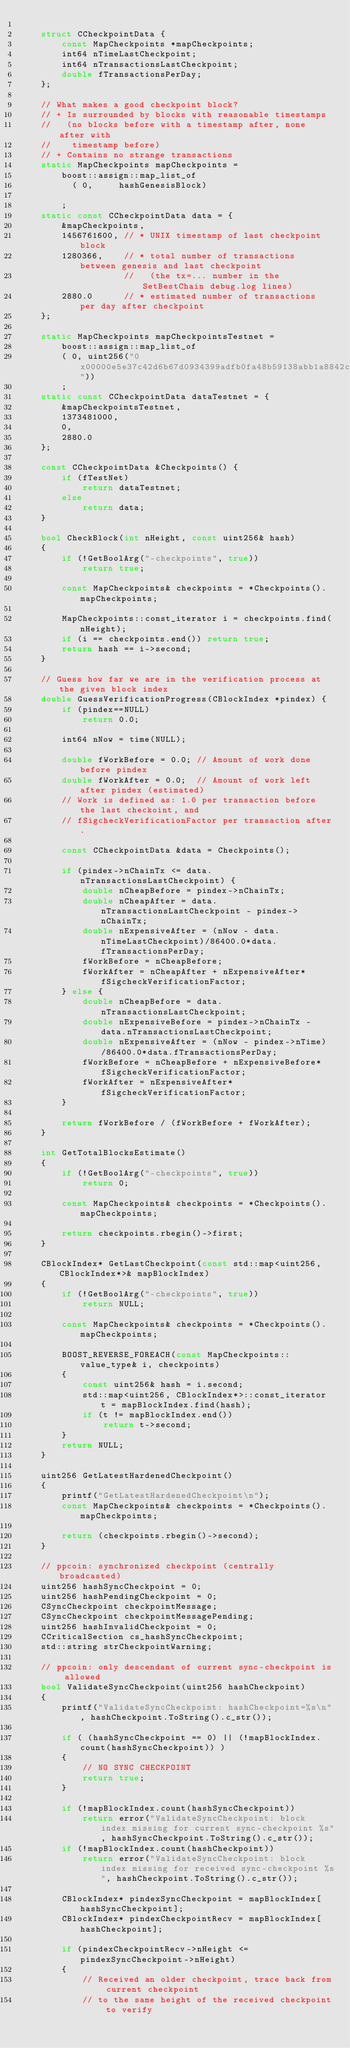<code> <loc_0><loc_0><loc_500><loc_500><_C++_>
    struct CCheckpointData {
        const MapCheckpoints *mapCheckpoints;
        int64 nTimeLastCheckpoint;
        int64 nTransactionsLastCheckpoint;
        double fTransactionsPerDay;
    };

    // What makes a good checkpoint block?
    // + Is surrounded by blocks with reasonable timestamps
    //   (no blocks before with a timestamp after, none after with
    //    timestamp before)
    // + Contains no strange transactions
    static MapCheckpoints mapCheckpoints =
        boost::assign::map_list_of
          ( 0,     hashGenesisBlock)

        ;
    static const CCheckpointData data = {
        &mapCheckpoints,
        1456761600, // * UNIX timestamp of last checkpoint block
        1280366,    // * total number of transactions between genesis and last checkpoint
                    //   (the tx=... number in the SetBestChain debug.log lines)
        2880.0      // * estimated number of transactions per day after checkpoint
    };

    static MapCheckpoints mapCheckpointsTestnet = 
        boost::assign::map_list_of
        ( 0, uint256("0x00000e5e37c42d6b67d0934399adfb0fa48b59138abb1a8842c88f4ca3d4ec96"))
        ;
    static const CCheckpointData dataTestnet = {
        &mapCheckpointsTestnet,
        1373481000,
        0,
        2880.0
    };

    const CCheckpointData &Checkpoints() {
        if (fTestNet)
            return dataTestnet;
        else
            return data;
    }

    bool CheckBlock(int nHeight, const uint256& hash)
    {
        if (!GetBoolArg("-checkpoints", true))
            return true;

        const MapCheckpoints& checkpoints = *Checkpoints().mapCheckpoints;

        MapCheckpoints::const_iterator i = checkpoints.find(nHeight);
        if (i == checkpoints.end()) return true;
        return hash == i->second;
    }

    // Guess how far we are in the verification process at the given block index
    double GuessVerificationProgress(CBlockIndex *pindex) {
        if (pindex==NULL)
            return 0.0;

        int64 nNow = time(NULL);

        double fWorkBefore = 0.0; // Amount of work done before pindex
        double fWorkAfter = 0.0;  // Amount of work left after pindex (estimated)
        // Work is defined as: 1.0 per transaction before the last checkoint, and
        // fSigcheckVerificationFactor per transaction after.

        const CCheckpointData &data = Checkpoints();

        if (pindex->nChainTx <= data.nTransactionsLastCheckpoint) {
            double nCheapBefore = pindex->nChainTx;
            double nCheapAfter = data.nTransactionsLastCheckpoint - pindex->nChainTx;
            double nExpensiveAfter = (nNow - data.nTimeLastCheckpoint)/86400.0*data.fTransactionsPerDay;
            fWorkBefore = nCheapBefore;
            fWorkAfter = nCheapAfter + nExpensiveAfter*fSigcheckVerificationFactor;
        } else {
            double nCheapBefore = data.nTransactionsLastCheckpoint;
            double nExpensiveBefore = pindex->nChainTx - data.nTransactionsLastCheckpoint;
            double nExpensiveAfter = (nNow - pindex->nTime)/86400.0*data.fTransactionsPerDay;
            fWorkBefore = nCheapBefore + nExpensiveBefore*fSigcheckVerificationFactor;
            fWorkAfter = nExpensiveAfter*fSigcheckVerificationFactor;
        }

        return fWorkBefore / (fWorkBefore + fWorkAfter);
    }

    int GetTotalBlocksEstimate()
    {
        if (!GetBoolArg("-checkpoints", true))
            return 0;

        const MapCheckpoints& checkpoints = *Checkpoints().mapCheckpoints;

        return checkpoints.rbegin()->first;
    }

    CBlockIndex* GetLastCheckpoint(const std::map<uint256, CBlockIndex*>& mapBlockIndex)
    {
        if (!GetBoolArg("-checkpoints", true))
            return NULL;

        const MapCheckpoints& checkpoints = *Checkpoints().mapCheckpoints;

        BOOST_REVERSE_FOREACH(const MapCheckpoints::value_type& i, checkpoints)
        {
            const uint256& hash = i.second;
            std::map<uint256, CBlockIndex*>::const_iterator t = mapBlockIndex.find(hash);
            if (t != mapBlockIndex.end())
                return t->second;
        }
        return NULL;
    }
    
    uint256 GetLatestHardenedCheckpoint()
    {
        printf("GetLatestHardenedCheckpoint\n");
        const MapCheckpoints& checkpoints = *Checkpoints().mapCheckpoints;
        
        return (checkpoints.rbegin()->second);
    }
 
    // ppcoin: synchronized checkpoint (centrally broadcasted)
    uint256 hashSyncCheckpoint = 0;
    uint256 hashPendingCheckpoint = 0;
    CSyncCheckpoint checkpointMessage;
    CSyncCheckpoint checkpointMessagePending;
    uint256 hashInvalidCheckpoint = 0;
    CCriticalSection cs_hashSyncCheckpoint;
    std::string strCheckpointWarning;   
    
    // ppcoin: only descendant of current sync-checkpoint is allowed
    bool ValidateSyncCheckpoint(uint256 hashCheckpoint)
    {
        printf("ValidateSyncCheckpoint: hashCheckpoint=%s\n", hashCheckpoint.ToString().c_str());
        
        if ( (hashSyncCheckpoint == 0) || (!mapBlockIndex.count(hashSyncCheckpoint)) )
        {
            // NO SYNC CHECKPOINT
            return true;
        }
        
        if (!mapBlockIndex.count(hashSyncCheckpoint))
            return error("ValidateSyncCheckpoint: block index missing for current sync-checkpoint %s", hashSyncCheckpoint.ToString().c_str());
        if (!mapBlockIndex.count(hashCheckpoint))
            return error("ValidateSyncCheckpoint: block index missing for received sync-checkpoint %s", hashCheckpoint.ToString().c_str());
        
        CBlockIndex* pindexSyncCheckpoint = mapBlockIndex[hashSyncCheckpoint];
        CBlockIndex* pindexCheckpointRecv = mapBlockIndex[hashCheckpoint];

        if (pindexCheckpointRecv->nHeight <= pindexSyncCheckpoint->nHeight)
        {
            // Received an older checkpoint, trace back from current checkpoint
            // to the same height of the received checkpoint to verify</code> 